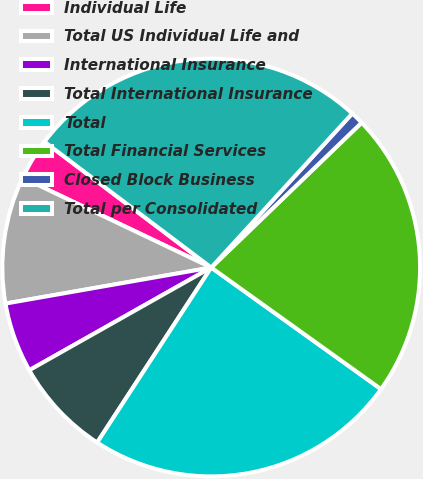Convert chart to OTSL. <chart><loc_0><loc_0><loc_500><loc_500><pie_chart><fcel>Individual Life<fcel>Total US Individual Life and<fcel>International Insurance<fcel>Total International Insurance<fcel>Total<fcel>Total Financial Services<fcel>Closed Block Business<fcel>Total per Consolidated<nl><fcel>3.21%<fcel>9.84%<fcel>5.42%<fcel>7.63%<fcel>24.31%<fcel>22.1%<fcel>1.0%<fcel>26.52%<nl></chart> 